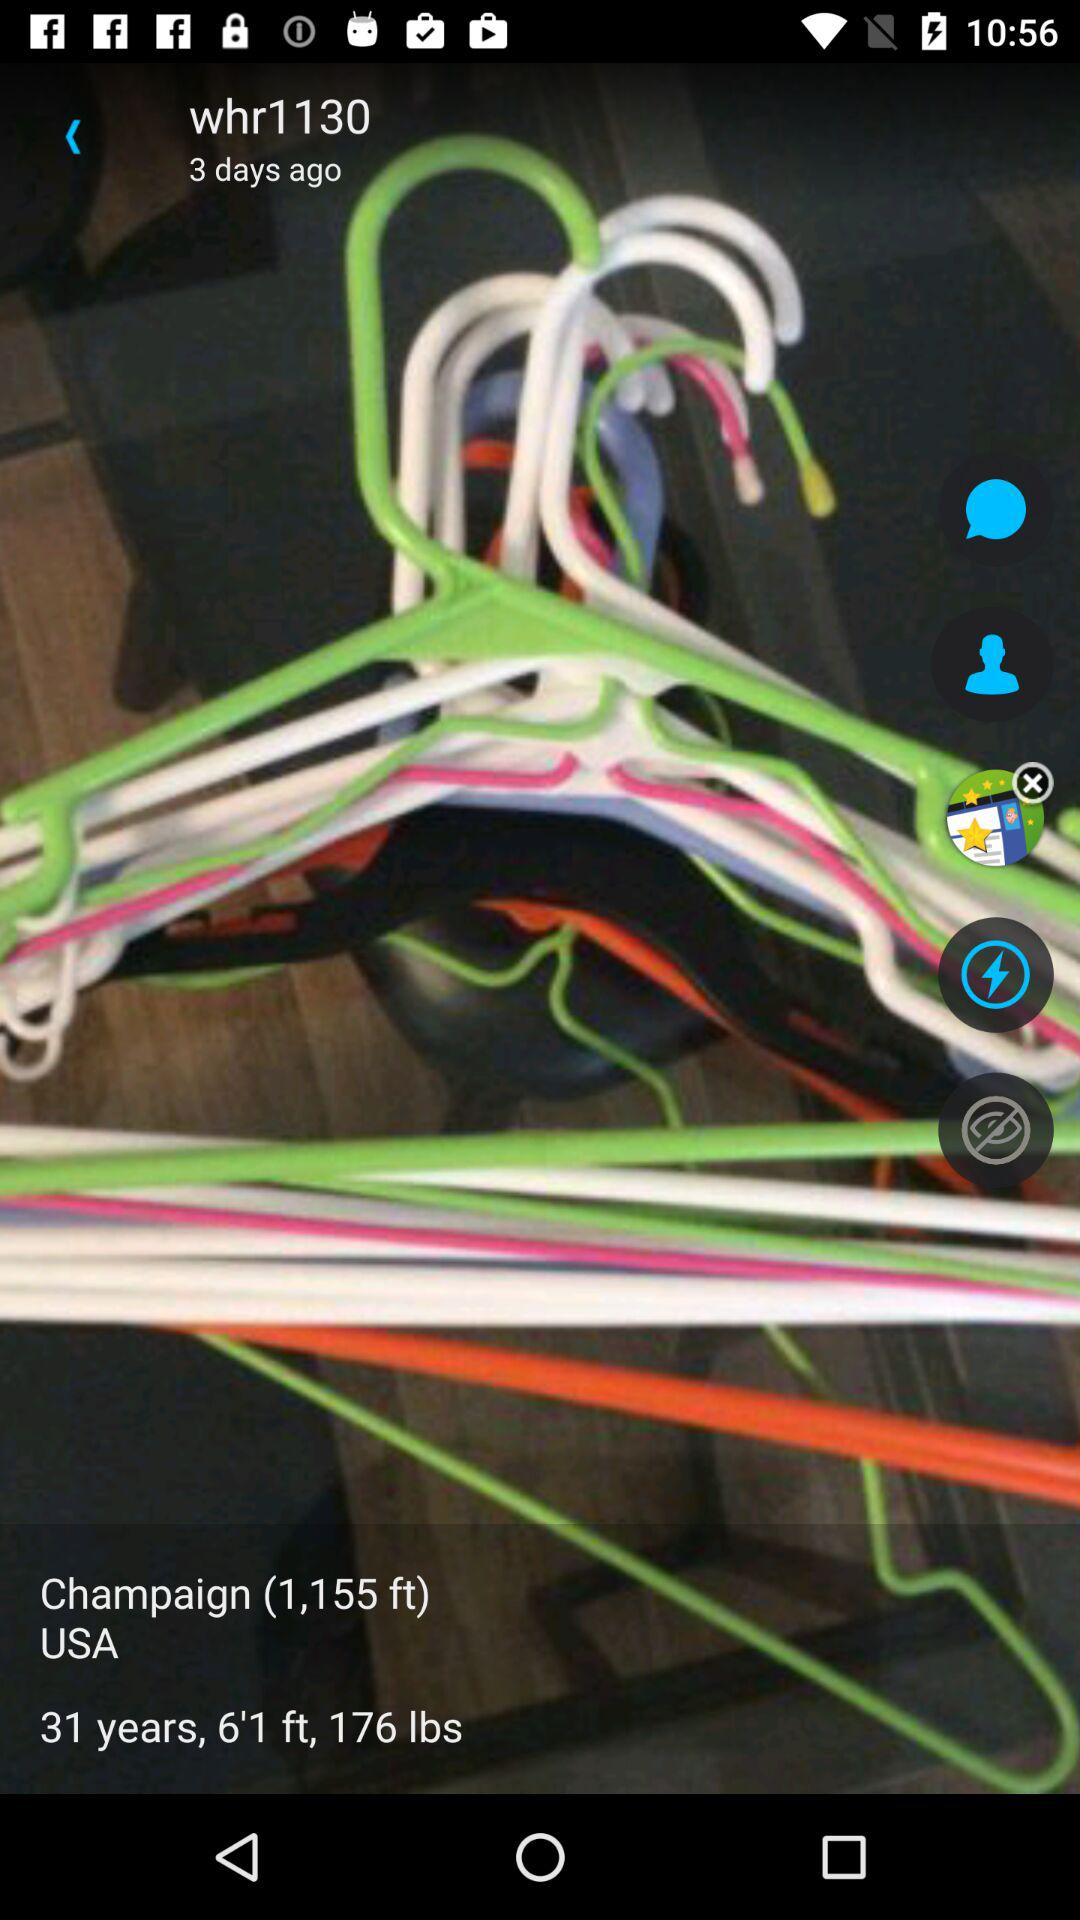What is the height? The height is 6'1 feet. 